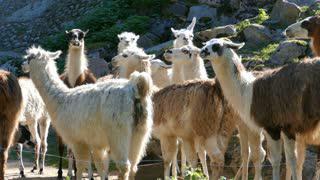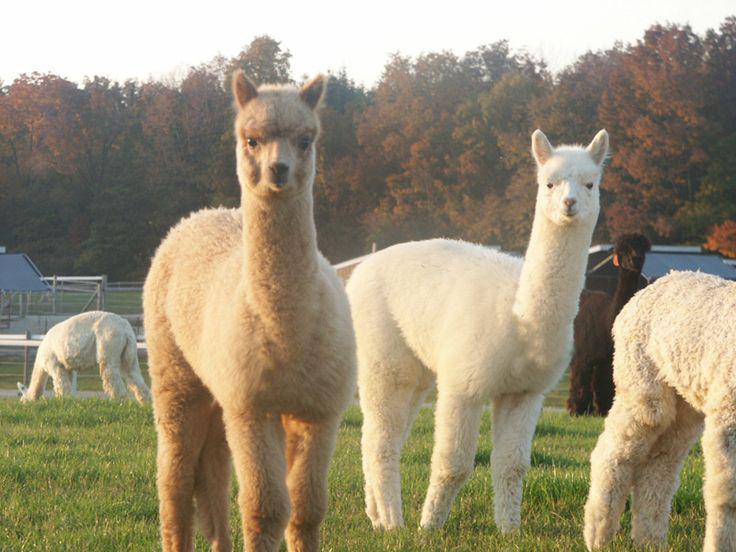The first image is the image on the left, the second image is the image on the right. For the images displayed, is the sentence "There are at least two alpacas one fully white and the other light brown facing and looking straight forward ." factually correct? Answer yes or no. Yes. The first image is the image on the left, the second image is the image on the right. Evaluate the accuracy of this statement regarding the images: "The foreground of the right image shows only camera-gazing llamas with solid colored fur.". Is it true? Answer yes or no. Yes. 